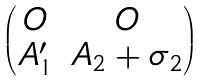<formula> <loc_0><loc_0><loc_500><loc_500>\begin{pmatrix} O & O \\ A _ { 1 } ^ { \prime } & A _ { 2 } + \sigma _ { 2 } \end{pmatrix}</formula> 